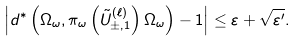Convert formula to latex. <formula><loc_0><loc_0><loc_500><loc_500>\left | d ^ { \ast } \left ( \Omega _ { \omega } , \pi _ { \omega } \left ( { \tilde { U } } _ { \pm , 1 } ^ { ( \ell ) } \right ) \Omega _ { \omega } \right ) - 1 \right | \leq \varepsilon + \sqrt { \varepsilon ^ { \prime } } .</formula> 